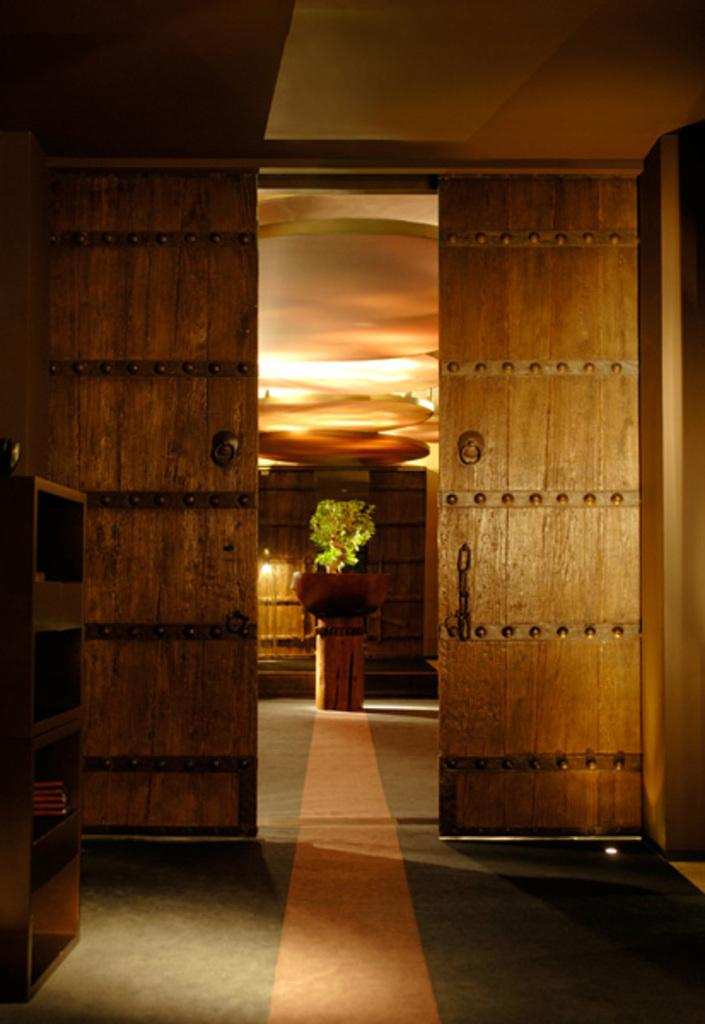What is on the floor in the image? There is a rack on the floor in the image. What can be seen in the image that might provide access to different rooms or areas? There are doors visible in the image. What type of plant is present in the image? There is a houseplant in the image. What can be seen in the background of the image? There are objects in the background of the image. What type of toy is being used by the government in the image? There is no toy or government present in the image. How many matches are visible in the image? There are no matches present in the image. 